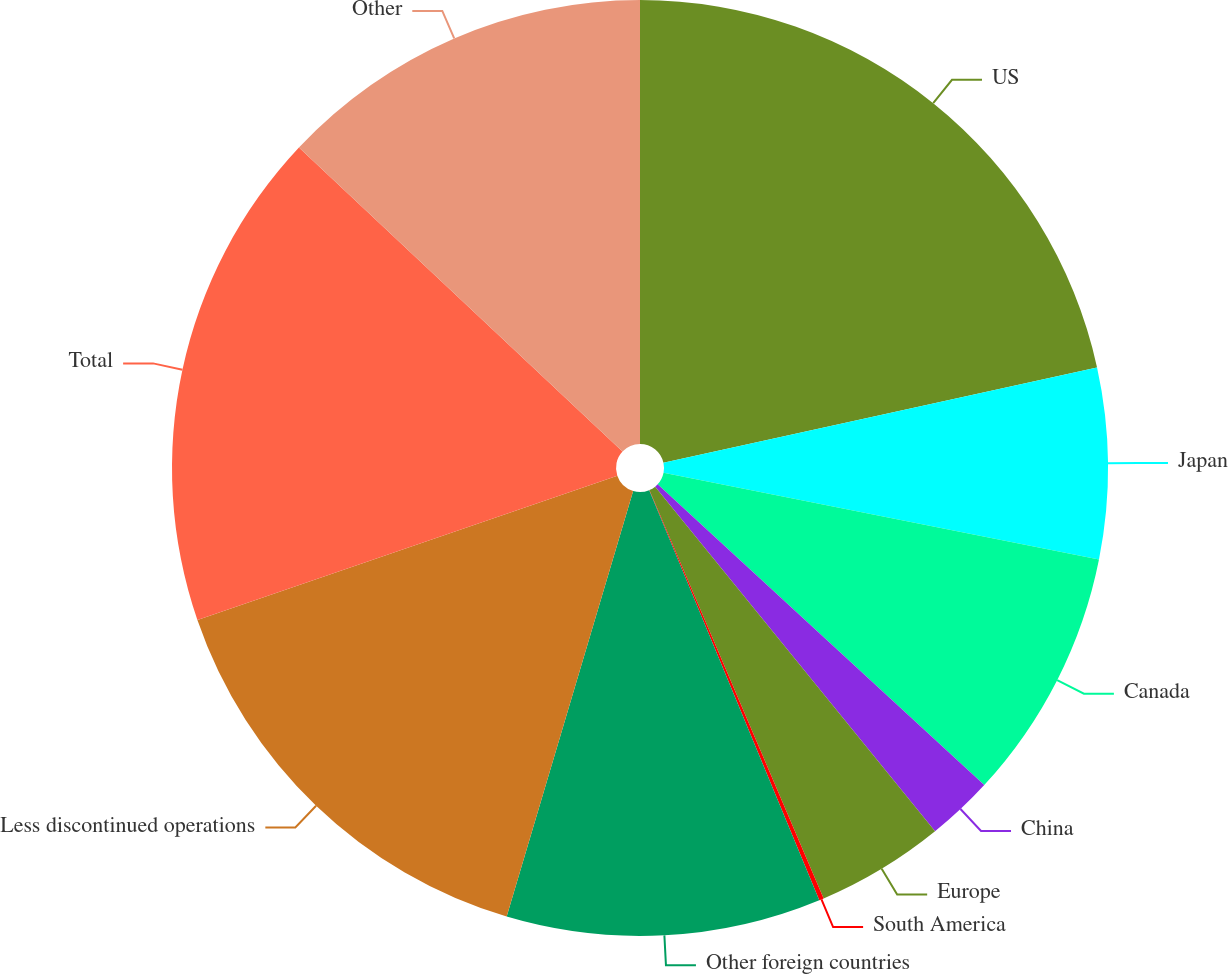Convert chart to OTSL. <chart><loc_0><loc_0><loc_500><loc_500><pie_chart><fcel>US<fcel>Japan<fcel>Canada<fcel>China<fcel>Europe<fcel>South America<fcel>Other foreign countries<fcel>Less discontinued operations<fcel>Total<fcel>Other<nl><fcel>21.56%<fcel>6.58%<fcel>8.72%<fcel>2.3%<fcel>4.44%<fcel>0.16%<fcel>10.86%<fcel>15.14%<fcel>17.28%<fcel>13.0%<nl></chart> 